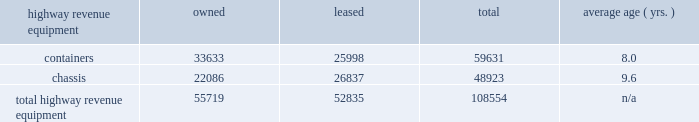Average highway revenue equipment owned leased total age ( yrs. ) .
Capital expenditures our rail network requires significant annual capital investments for replacement , improvement , and expansion .
These investments enhance safety , support the transportation needs of our customers , and improve our operational efficiency .
Additionally , we add new locomotives and freight cars to our fleet to replace older , less efficient equipment , to support growth and customer demand , and to reduce our impact on the environment through the acquisition of more fuel-efficient and low-emission locomotives .
2015 capital program 2013 during 2015 , our capital program totaled $ 4.3 billion .
( see the cash capital expenditures table in management 2019s discussion and analysis of financial condition and results of operations 2013 liquidity and capital resources , item 7. ) 2016 capital plan 2013 in 2016 , we expect our capital plan to be approximately $ 3.75 billion , which will include expenditures for ptc of approximately $ 375 million and may include non-cash investments .
We may revise our 2016 capital plan if business conditions warrant or if new laws or regulations affect our ability to generate sufficient returns on these investments .
( see discussion of our 2016 capital plan in management 2019s discussion and analysis of financial condition and results of operations 2013 2016 outlook , item 7. ) equipment encumbrances 2013 equipment with a carrying value of approximately $ 2.6 billion and $ 2.8 billion at december 31 , 2015 , and 2014 , respectively served as collateral for capital leases and other types of equipment obligations in accordance with the secured financing arrangements utilized to acquire or refinance such railroad equipment .
As a result of the merger of missouri pacific railroad company ( mprr ) with and into uprr on january 1 , 1997 , and pursuant to the underlying indentures for the mprr mortgage bonds , uprr must maintain the same value of assets after the merger in order to comply with the security requirements of the mortgage bonds .
As of the merger date , the value of the mprr assets that secured the mortgage bonds was approximately $ 6.0 billion .
In accordance with the terms of the indentures , this collateral value must be maintained during the entire term of the mortgage bonds irrespective of the outstanding balance of such bonds .
Environmental matters 2013 certain of our properties are subject to federal , state , and local laws and regulations governing the protection of the environment .
( see discussion of environmental issues in business 2013 governmental and environmental regulation , item 1 , and management 2019s discussion and analysis of financial condition and results of operations 2013 critical accounting policies 2013 environmental , item 7. ) item 3 .
Legal proceedings from time to time , we are involved in legal proceedings , claims , and litigation that occur in connection with our business .
We routinely assess our liabilities and contingencies in connection with these matters based upon the latest available information and , when necessary , we seek input from our third-party advisors when making these assessments .
Consistent with sec rules and requirements , we describe below material pending legal proceedings ( other than ordinary routine litigation incidental to our business ) , material proceedings known to be contemplated by governmental authorities , other proceedings arising under federal , state , or local environmental laws and regulations ( including governmental proceedings involving potential fines , penalties , or other monetary sanctions in excess of $ 100000 ) , and such other pending matters that we may determine to be appropriate. .
What percentage of total highway revenue equipment owned is containers? 
Computations: (33633 / 55719)
Answer: 0.60362. 